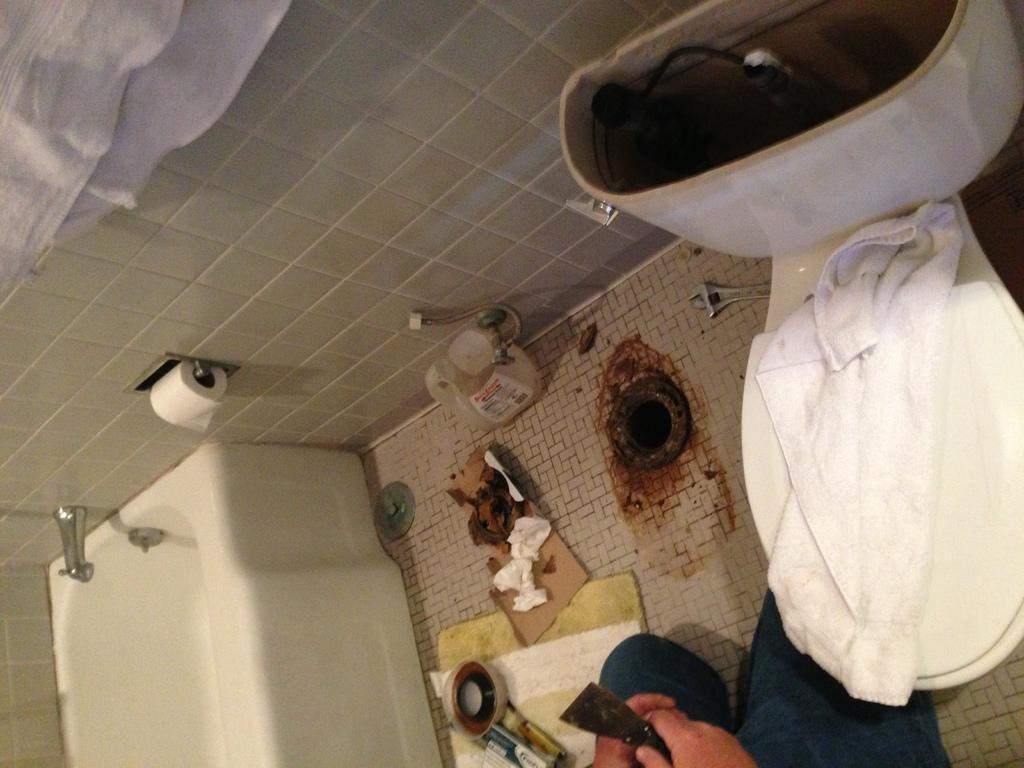Please provide a concise description of this image. The image is taken in the bathroom. On the left side of the image we can see a bathtub. On the right there is a flush tank and we can see a napkin on it. At the bottom we can see a person holding an object. In the center there is a bottle and we can see some things placed on the floor. 